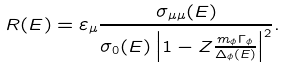<formula> <loc_0><loc_0><loc_500><loc_500>R ( E ) = \varepsilon _ { \mu } \frac { \sigma _ { \mu \mu } ( E ) } { \sigma _ { 0 } ( E ) \left | 1 - Z \frac { m _ { \phi } \Gamma _ { \phi } } { \Delta _ { \phi } ( E ) } \right | ^ { 2 } } .</formula> 